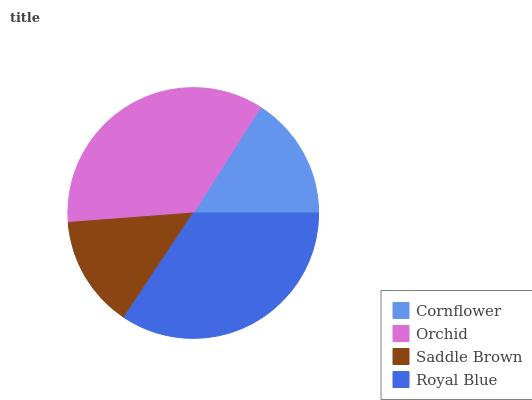Is Saddle Brown the minimum?
Answer yes or no. Yes. Is Orchid the maximum?
Answer yes or no. Yes. Is Orchid the minimum?
Answer yes or no. No. Is Saddle Brown the maximum?
Answer yes or no. No. Is Orchid greater than Saddle Brown?
Answer yes or no. Yes. Is Saddle Brown less than Orchid?
Answer yes or no. Yes. Is Saddle Brown greater than Orchid?
Answer yes or no. No. Is Orchid less than Saddle Brown?
Answer yes or no. No. Is Royal Blue the high median?
Answer yes or no. Yes. Is Cornflower the low median?
Answer yes or no. Yes. Is Saddle Brown the high median?
Answer yes or no. No. Is Royal Blue the low median?
Answer yes or no. No. 